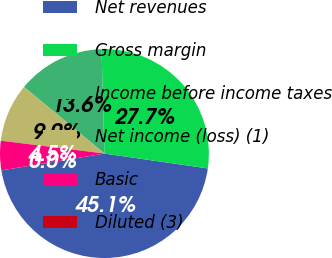Convert chart to OTSL. <chart><loc_0><loc_0><loc_500><loc_500><pie_chart><fcel>Net revenues<fcel>Gross margin<fcel>Income before income taxes<fcel>Net income (loss) (1)<fcel>Basic<fcel>Diluted (3)<nl><fcel>45.14%<fcel>27.72%<fcel>13.55%<fcel>9.04%<fcel>4.53%<fcel>0.02%<nl></chart> 